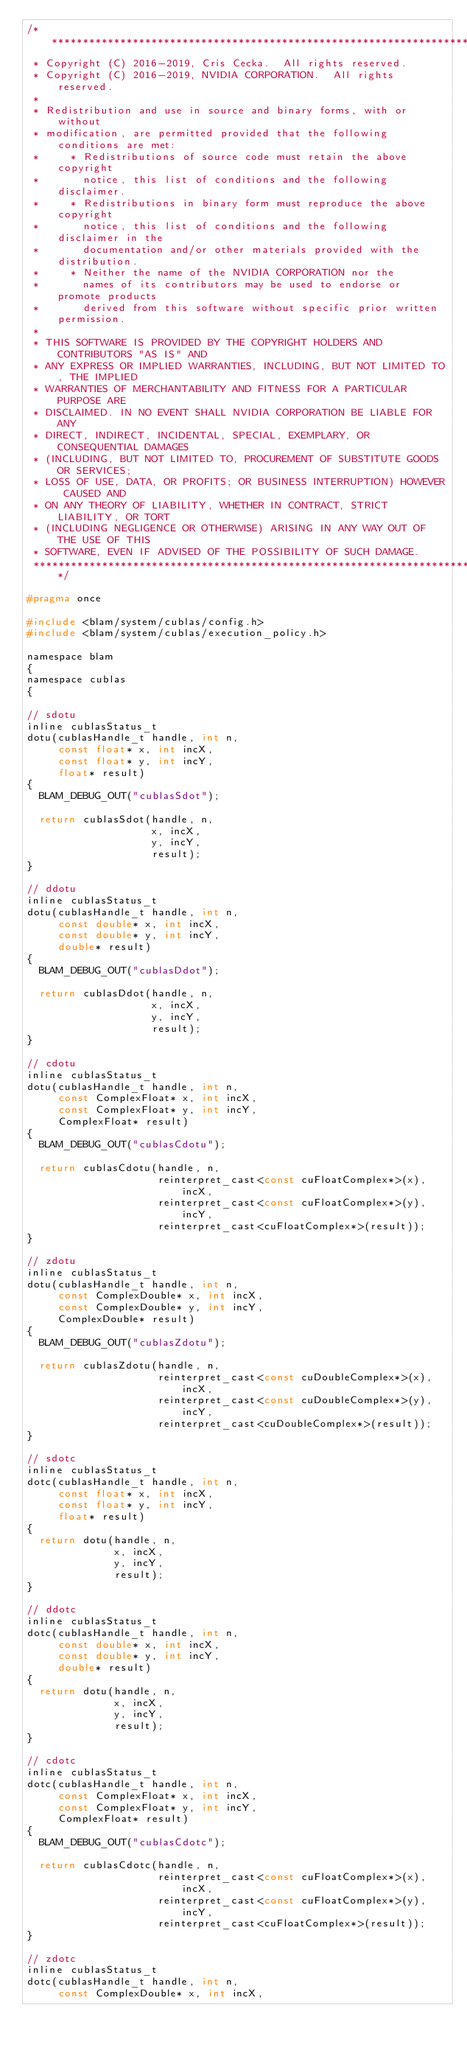<code> <loc_0><loc_0><loc_500><loc_500><_C_>/******************************************************************************
 * Copyright (C) 2016-2019, Cris Cecka.  All rights reserved.
 * Copyright (C) 2016-2019, NVIDIA CORPORATION.  All rights reserved.
 *
 * Redistribution and use in source and binary forms, with or without
 * modification, are permitted provided that the following conditions are met:
 *     * Redistributions of source code must retain the above copyright
 *       notice, this list of conditions and the following disclaimer.
 *     * Redistributions in binary form must reproduce the above copyright
 *       notice, this list of conditions and the following disclaimer in the
 *       documentation and/or other materials provided with the distribution.
 *     * Neither the name of the NVIDIA CORPORATION nor the
 *       names of its contributors may be used to endorse or promote products
 *       derived from this software without specific prior written permission.
 *
 * THIS SOFTWARE IS PROVIDED BY THE COPYRIGHT HOLDERS AND CONTRIBUTORS "AS IS" AND
 * ANY EXPRESS OR IMPLIED WARRANTIES, INCLUDING, BUT NOT LIMITED TO, THE IMPLIED
 * WARRANTIES OF MERCHANTABILITY AND FITNESS FOR A PARTICULAR PURPOSE ARE
 * DISCLAIMED. IN NO EVENT SHALL NVIDIA CORPORATION BE LIABLE FOR ANY
 * DIRECT, INDIRECT, INCIDENTAL, SPECIAL, EXEMPLARY, OR CONSEQUENTIAL DAMAGES
 * (INCLUDING, BUT NOT LIMITED TO, PROCUREMENT OF SUBSTITUTE GOODS OR SERVICES;
 * LOSS OF USE, DATA, OR PROFITS; OR BUSINESS INTERRUPTION) HOWEVER CAUSED AND
 * ON ANY THEORY OF LIABILITY, WHETHER IN CONTRACT, STRICT LIABILITY, OR TORT
 * (INCLUDING NEGLIGENCE OR OTHERWISE) ARISING IN ANY WAY OUT OF THE USE OF THIS
 * SOFTWARE, EVEN IF ADVISED OF THE POSSIBILITY OF SUCH DAMAGE.
 ******************************************************************************/

#pragma once

#include <blam/system/cublas/config.h>
#include <blam/system/cublas/execution_policy.h>

namespace blam
{
namespace cublas
{

// sdotu
inline cublasStatus_t
dotu(cublasHandle_t handle, int n,
     const float* x, int incX,
     const float* y, int incY,
     float* result)
{
  BLAM_DEBUG_OUT("cublasSdot");

  return cublasSdot(handle, n,
                    x, incX,
                    y, incY,
                    result);
}

// ddotu
inline cublasStatus_t
dotu(cublasHandle_t handle, int n,
     const double* x, int incX,
     const double* y, int incY,
     double* result)
{
  BLAM_DEBUG_OUT("cublasDdot");

  return cublasDdot(handle, n,
                    x, incX,
                    y, incY,
                    result);
}

// cdotu
inline cublasStatus_t
dotu(cublasHandle_t handle, int n,
     const ComplexFloat* x, int incX,
     const ComplexFloat* y, int incY,
     ComplexFloat* result)
{
  BLAM_DEBUG_OUT("cublasCdotu");

  return cublasCdotu(handle, n,
                     reinterpret_cast<const cuFloatComplex*>(x), incX,
                     reinterpret_cast<const cuFloatComplex*>(y), incY,
                     reinterpret_cast<cuFloatComplex*>(result));
}

// zdotu
inline cublasStatus_t
dotu(cublasHandle_t handle, int n,
     const ComplexDouble* x, int incX,
     const ComplexDouble* y, int incY,
     ComplexDouble* result)
{
  BLAM_DEBUG_OUT("cublasZdotu");

  return cublasZdotu(handle, n,
                     reinterpret_cast<const cuDoubleComplex*>(x), incX,
                     reinterpret_cast<const cuDoubleComplex*>(y), incY,
                     reinterpret_cast<cuDoubleComplex*>(result));
}

// sdotc
inline cublasStatus_t
dotc(cublasHandle_t handle, int n,
     const float* x, int incX,
     const float* y, int incY,
     float* result)
{
  return dotu(handle, n,
              x, incX,
              y, incY,
              result);
}

// ddotc
inline cublasStatus_t
dotc(cublasHandle_t handle, int n,
     const double* x, int incX,
     const double* y, int incY,
     double* result)
{
  return dotu(handle, n,
              x, incX,
              y, incY,
              result);
}

// cdotc
inline cublasStatus_t
dotc(cublasHandle_t handle, int n,
     const ComplexFloat* x, int incX,
     const ComplexFloat* y, int incY,
     ComplexFloat* result)
{
  BLAM_DEBUG_OUT("cublasCdotc");

  return cublasCdotc(handle, n,
                     reinterpret_cast<const cuFloatComplex*>(x), incX,
                     reinterpret_cast<const cuFloatComplex*>(y), incY,
                     reinterpret_cast<cuFloatComplex*>(result));
}

// zdotc
inline cublasStatus_t
dotc(cublasHandle_t handle, int n,
     const ComplexDouble* x, int incX,</code> 